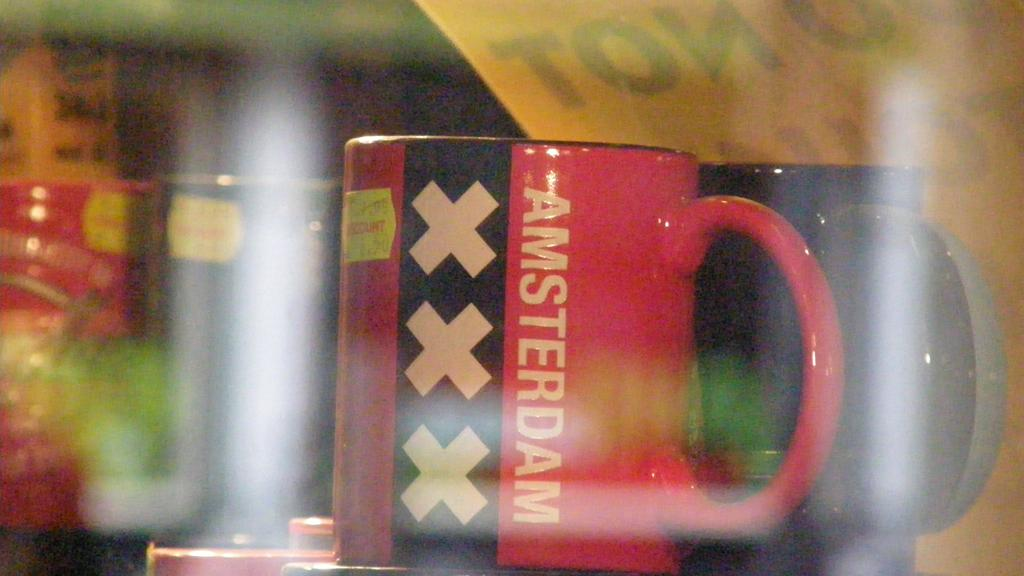<image>
Write a terse but informative summary of the picture. Coffee mug that has three x's and Amsterdam on it. 